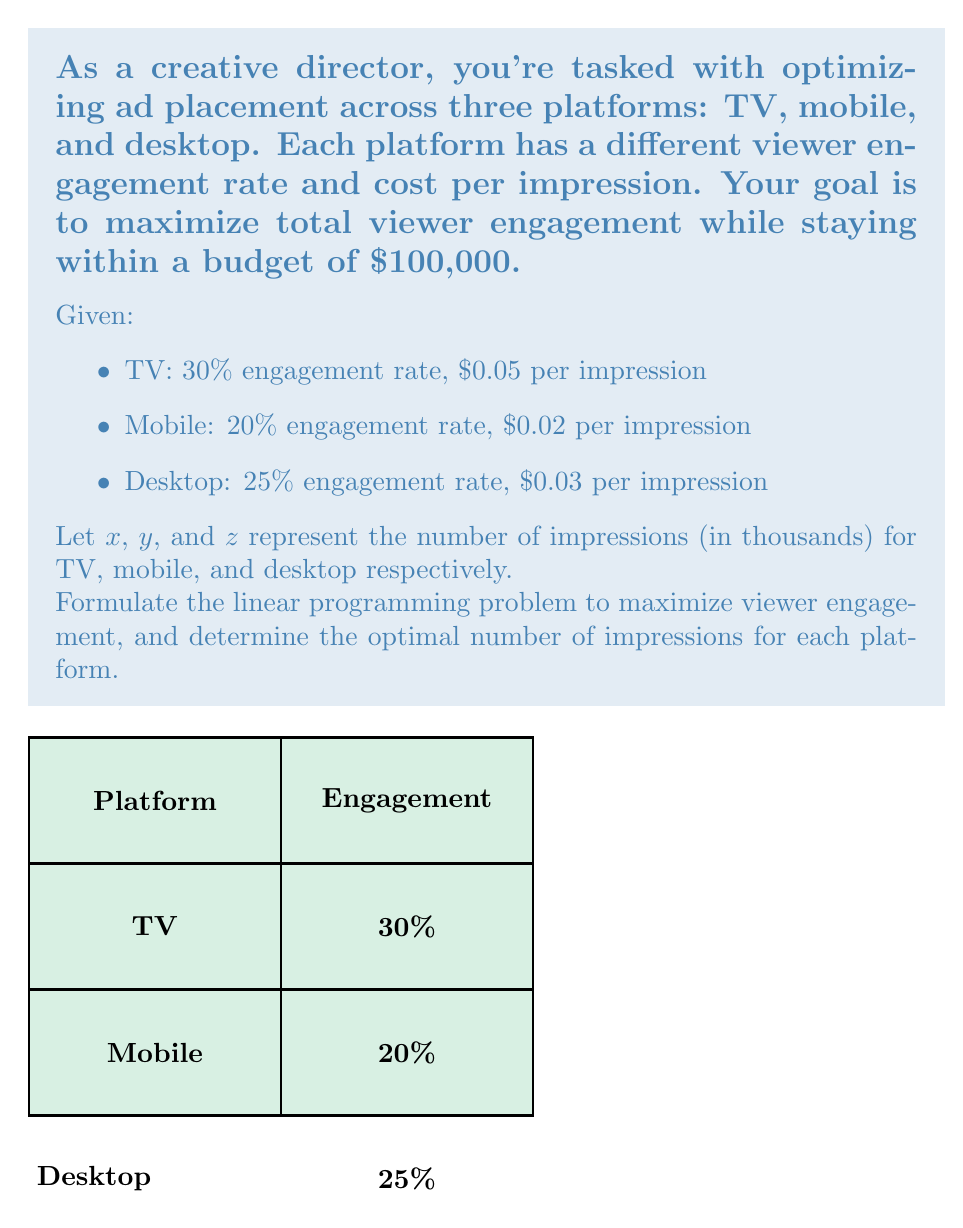What is the answer to this math problem? Let's solve this step-by-step:

1) Objective function:
   We want to maximize total engagement. For each platform, engagement is the product of the number of impressions and the engagement rate.
   
   Maximize: $Z = 0.30x + 0.20y + 0.25z$

2) Constraints:
   a) Budget constraint: The total cost must not exceed $100,000
      $0.05x + 0.02y + 0.03z \leq 100$
      (Note: x, y, z are in thousands, so we divide the budget by 1000)

   b) Non-negativity constraints:
      $x \geq 0$, $y \geq 0$, $z \geq 0$

3) The complete linear programming problem:

   Maximize: $Z = 0.30x + 0.20y + 0.25z$
   Subject to:
   $0.05x + 0.02y + 0.03z \leq 100$
   $x, y, z \geq 0$

4) To solve this, we can use the simplex method or linear programming software. The optimal solution is:

   $x = 0$ (TV)
   $y = 3333.33$ (Mobile)
   $z = 1111.11$ (Desktop)

5) This solution allocates:
   - 0 impressions to TV
   - 3,333,330 impressions to mobile
   - 1,111,110 impressions to desktop

6) The maximum engagement achieved is:
   $Z = 0.30(0) + 0.20(3333.33) + 0.25(1111.11) = 944.44$ (thousand engagements)

7) We can verify that this solution meets the budget constraint:
   $0.05(0) + 0.02(3333.33) + 0.03(1111.11) = 100$ (thousand dollars)

This solution suggests focusing entirely on mobile and desktop platforms for maximum engagement within the given budget.
Answer: TV: 0, Mobile: 3,333,330, Desktop: 1,111,110 impressions 